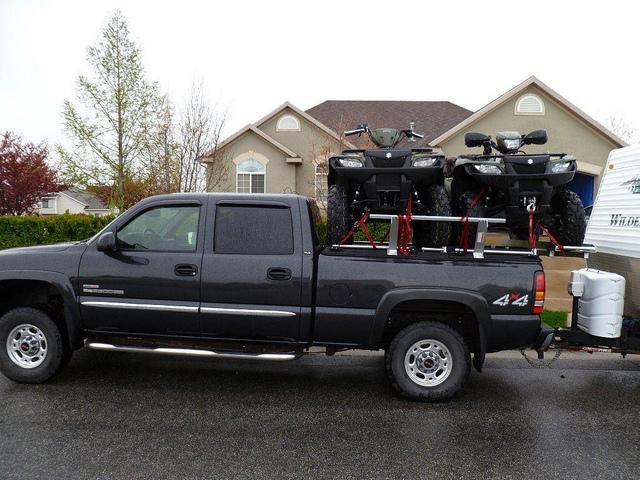How many four wheelers are there?
Give a very brief answer. 2. How many brake lights are in this photo?
Give a very brief answer. 1. How many people are there?
Give a very brief answer. 0. 